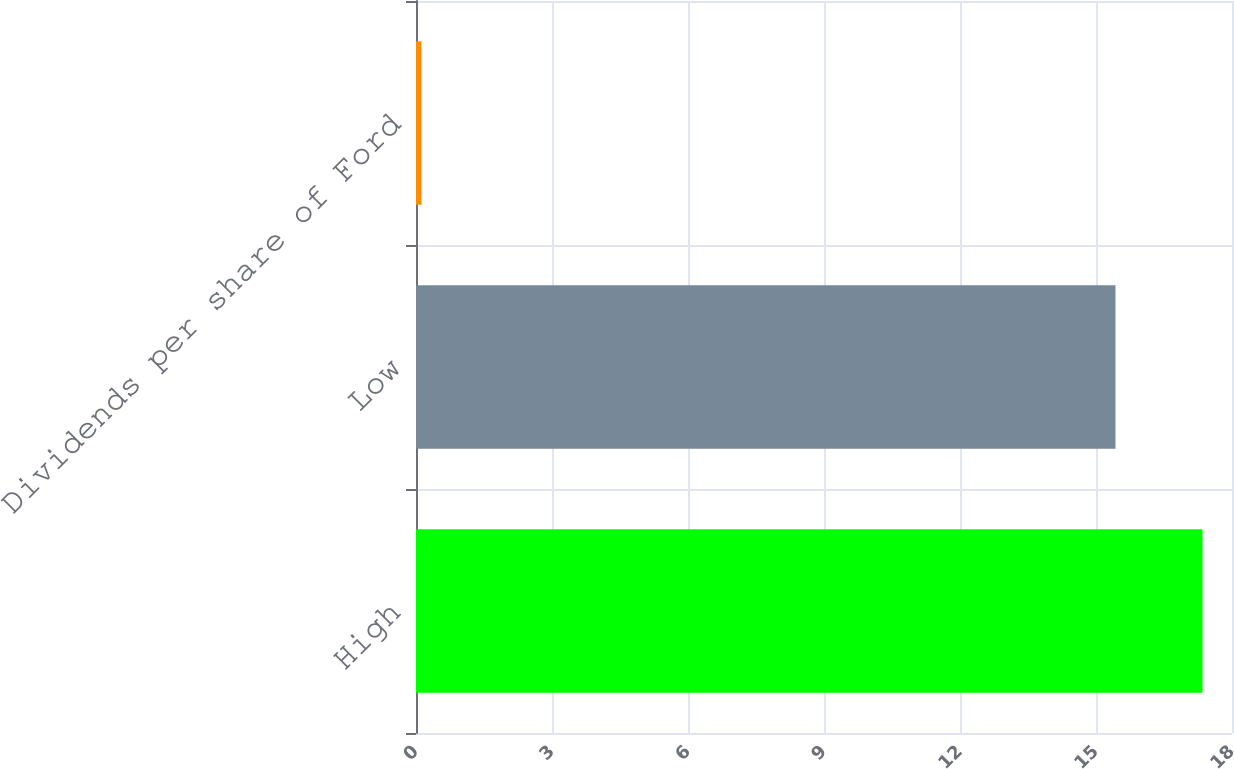Convert chart. <chart><loc_0><loc_0><loc_500><loc_500><bar_chart><fcel>High<fcel>Low<fcel>Dividends per share of Ford<nl><fcel>17.35<fcel>15.43<fcel>0.12<nl></chart> 